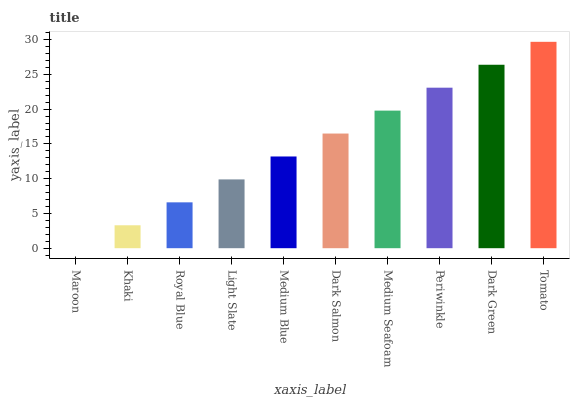Is Maroon the minimum?
Answer yes or no. Yes. Is Tomato the maximum?
Answer yes or no. Yes. Is Khaki the minimum?
Answer yes or no. No. Is Khaki the maximum?
Answer yes or no. No. Is Khaki greater than Maroon?
Answer yes or no. Yes. Is Maroon less than Khaki?
Answer yes or no. Yes. Is Maroon greater than Khaki?
Answer yes or no. No. Is Khaki less than Maroon?
Answer yes or no. No. Is Dark Salmon the high median?
Answer yes or no. Yes. Is Medium Blue the low median?
Answer yes or no. Yes. Is Medium Blue the high median?
Answer yes or no. No. Is Royal Blue the low median?
Answer yes or no. No. 